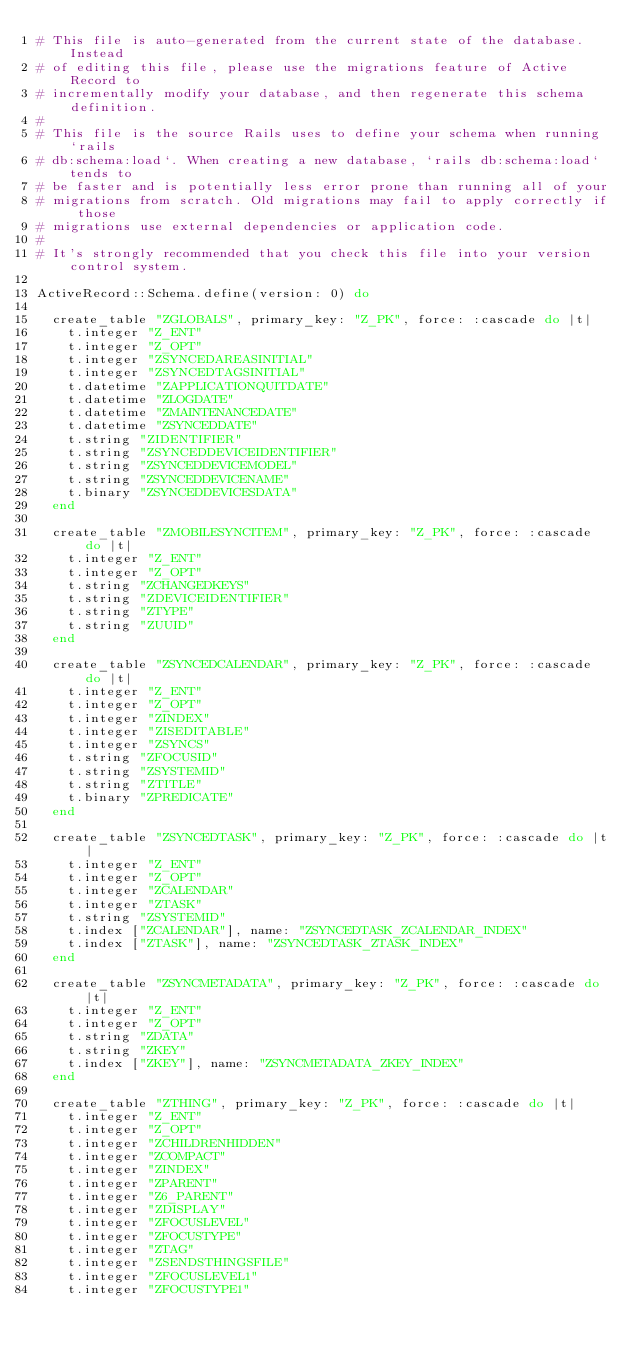<code> <loc_0><loc_0><loc_500><loc_500><_Ruby_># This file is auto-generated from the current state of the database. Instead
# of editing this file, please use the migrations feature of Active Record to
# incrementally modify your database, and then regenerate this schema definition.
#
# This file is the source Rails uses to define your schema when running `rails
# db:schema:load`. When creating a new database, `rails db:schema:load` tends to
# be faster and is potentially less error prone than running all of your
# migrations from scratch. Old migrations may fail to apply correctly if those
# migrations use external dependencies or application code.
#
# It's strongly recommended that you check this file into your version control system.

ActiveRecord::Schema.define(version: 0) do

  create_table "ZGLOBALS", primary_key: "Z_PK", force: :cascade do |t|
    t.integer "Z_ENT"
    t.integer "Z_OPT"
    t.integer "ZSYNCEDAREASINITIAL"
    t.integer "ZSYNCEDTAGSINITIAL"
    t.datetime "ZAPPLICATIONQUITDATE"
    t.datetime "ZLOGDATE"
    t.datetime "ZMAINTENANCEDATE"
    t.datetime "ZSYNCEDDATE"
    t.string "ZIDENTIFIER"
    t.string "ZSYNCEDDEVICEIDENTIFIER"
    t.string "ZSYNCEDDEVICEMODEL"
    t.string "ZSYNCEDDEVICENAME"
    t.binary "ZSYNCEDDEVICESDATA"
  end

  create_table "ZMOBILESYNCITEM", primary_key: "Z_PK", force: :cascade do |t|
    t.integer "Z_ENT"
    t.integer "Z_OPT"
    t.string "ZCHANGEDKEYS"
    t.string "ZDEVICEIDENTIFIER"
    t.string "ZTYPE"
    t.string "ZUUID"
  end

  create_table "ZSYNCEDCALENDAR", primary_key: "Z_PK", force: :cascade do |t|
    t.integer "Z_ENT"
    t.integer "Z_OPT"
    t.integer "ZINDEX"
    t.integer "ZISEDITABLE"
    t.integer "ZSYNCS"
    t.string "ZFOCUSID"
    t.string "ZSYSTEMID"
    t.string "ZTITLE"
    t.binary "ZPREDICATE"
  end

  create_table "ZSYNCEDTASK", primary_key: "Z_PK", force: :cascade do |t|
    t.integer "Z_ENT"
    t.integer "Z_OPT"
    t.integer "ZCALENDAR"
    t.integer "ZTASK"
    t.string "ZSYSTEMID"
    t.index ["ZCALENDAR"], name: "ZSYNCEDTASK_ZCALENDAR_INDEX"
    t.index ["ZTASK"], name: "ZSYNCEDTASK_ZTASK_INDEX"
  end

  create_table "ZSYNCMETADATA", primary_key: "Z_PK", force: :cascade do |t|
    t.integer "Z_ENT"
    t.integer "Z_OPT"
    t.string "ZDATA"
    t.string "ZKEY"
    t.index ["ZKEY"], name: "ZSYNCMETADATA_ZKEY_INDEX"
  end

  create_table "ZTHING", primary_key: "Z_PK", force: :cascade do |t|
    t.integer "Z_ENT"
    t.integer "Z_OPT"
    t.integer "ZCHILDRENHIDDEN"
    t.integer "ZCOMPACT"
    t.integer "ZINDEX"
    t.integer "ZPARENT"
    t.integer "Z6_PARENT"
    t.integer "ZDISPLAY"
    t.integer "ZFOCUSLEVEL"
    t.integer "ZFOCUSTYPE"
    t.integer "ZTAG"
    t.integer "ZSENDSTHINGSFILE"
    t.integer "ZFOCUSLEVEL1"
    t.integer "ZFOCUSTYPE1"</code> 